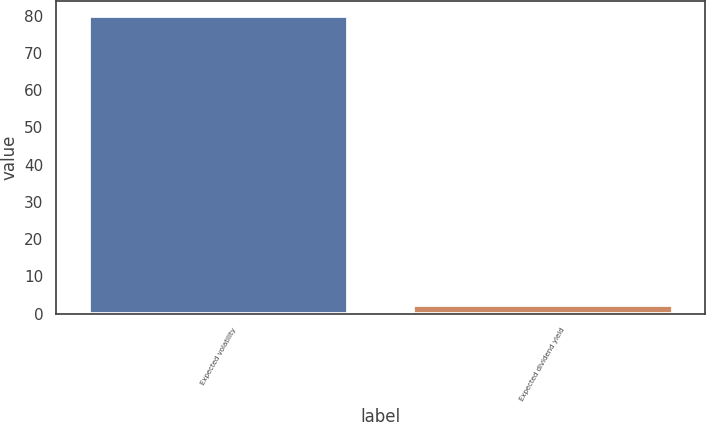Convert chart. <chart><loc_0><loc_0><loc_500><loc_500><bar_chart><fcel>Expected volatility<fcel>Expected dividend yield<nl><fcel>80<fcel>2.21<nl></chart> 